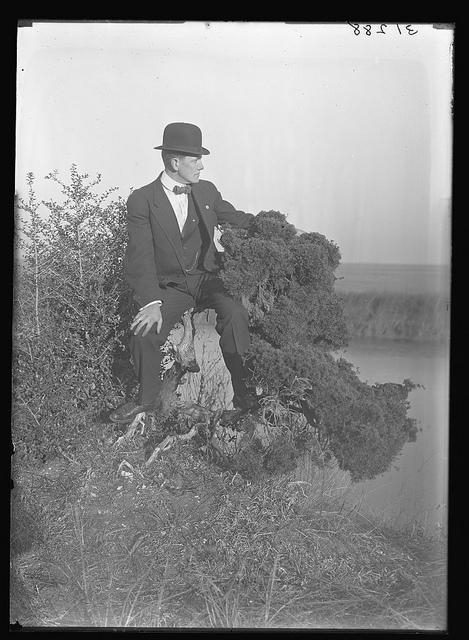Is the man wearing a scarf?
Be succinct. No. How many people are wearing hats?
Answer briefly. 1. Is the man standing?
Be succinct. No. Should he be wearing a helmet?
Write a very short answer. No. Is this a modern picture?
Answer briefly. No. Does he have on a bowler hat?
Write a very short answer. Yes. Is the man taking the picture balding?
Be succinct. No. Is the man wearing gloves?
Give a very brief answer. No. How many people are wearing hats in this photo?
Answer briefly. 1. What is the man wearing?
Concise answer only. Suit. What is the man doing?
Short answer required. Sitting. Where is the man sitting?
Be succinct. Tree stump. What decade was this photo likely taken?
Keep it brief. 1920s. What is the man squatting for?
Give a very brief answer. To sit. Does the man have something in his mouth?
Short answer required. No. Is he wearing knee pads?
Write a very short answer. No. Is there a lake in the photo?
Give a very brief answer. Yes. What color of pants are people wearing?
Be succinct. Black. Where is the person sitting?
Quick response, please. Rock. Is there a surfboard?
Write a very short answer. No. 